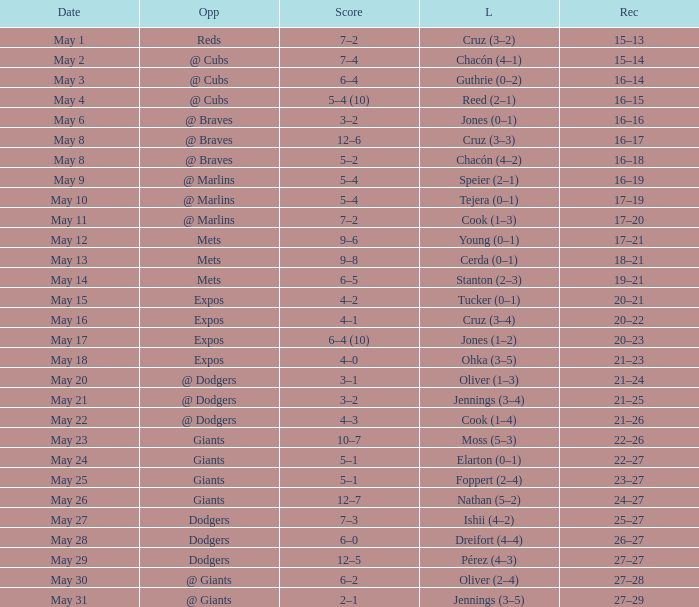Write the full table. {'header': ['Date', 'Opp', 'Score', 'L', 'Rec'], 'rows': [['May 1', 'Reds', '7–2', 'Cruz (3–2)', '15–13'], ['May 2', '@ Cubs', '7–4', 'Chacón (4–1)', '15–14'], ['May 3', '@ Cubs', '6–4', 'Guthrie (0–2)', '16–14'], ['May 4', '@ Cubs', '5–4 (10)', 'Reed (2–1)', '16–15'], ['May 6', '@ Braves', '3–2', 'Jones (0–1)', '16–16'], ['May 8', '@ Braves', '12–6', 'Cruz (3–3)', '16–17'], ['May 8', '@ Braves', '5–2', 'Chacón (4–2)', '16–18'], ['May 9', '@ Marlins', '5–4', 'Speier (2–1)', '16–19'], ['May 10', '@ Marlins', '5–4', 'Tejera (0–1)', '17–19'], ['May 11', '@ Marlins', '7–2', 'Cook (1–3)', '17–20'], ['May 12', 'Mets', '9–6', 'Young (0–1)', '17–21'], ['May 13', 'Mets', '9–8', 'Cerda (0–1)', '18–21'], ['May 14', 'Mets', '6–5', 'Stanton (2–3)', '19–21'], ['May 15', 'Expos', '4–2', 'Tucker (0–1)', '20–21'], ['May 16', 'Expos', '4–1', 'Cruz (3–4)', '20–22'], ['May 17', 'Expos', '6–4 (10)', 'Jones (1–2)', '20–23'], ['May 18', 'Expos', '4–0', 'Ohka (3–5)', '21–23'], ['May 20', '@ Dodgers', '3–1', 'Oliver (1–3)', '21–24'], ['May 21', '@ Dodgers', '3–2', 'Jennings (3–4)', '21–25'], ['May 22', '@ Dodgers', '4–3', 'Cook (1–4)', '21–26'], ['May 23', 'Giants', '10–7', 'Moss (5–3)', '22–26'], ['May 24', 'Giants', '5–1', 'Elarton (0–1)', '22–27'], ['May 25', 'Giants', '5–1', 'Foppert (2–4)', '23–27'], ['May 26', 'Giants', '12–7', 'Nathan (5–2)', '24–27'], ['May 27', 'Dodgers', '7–3', 'Ishii (4–2)', '25–27'], ['May 28', 'Dodgers', '6–0', 'Dreifort (4–4)', '26–27'], ['May 29', 'Dodgers', '12–5', 'Pérez (4–3)', '27–27'], ['May 30', '@ Giants', '6–2', 'Oliver (2–4)', '27–28'], ['May 31', '@ Giants', '2–1', 'Jennings (3–5)', '27–29']]} Tell me who was the opponent on May 6 @ Braves. 